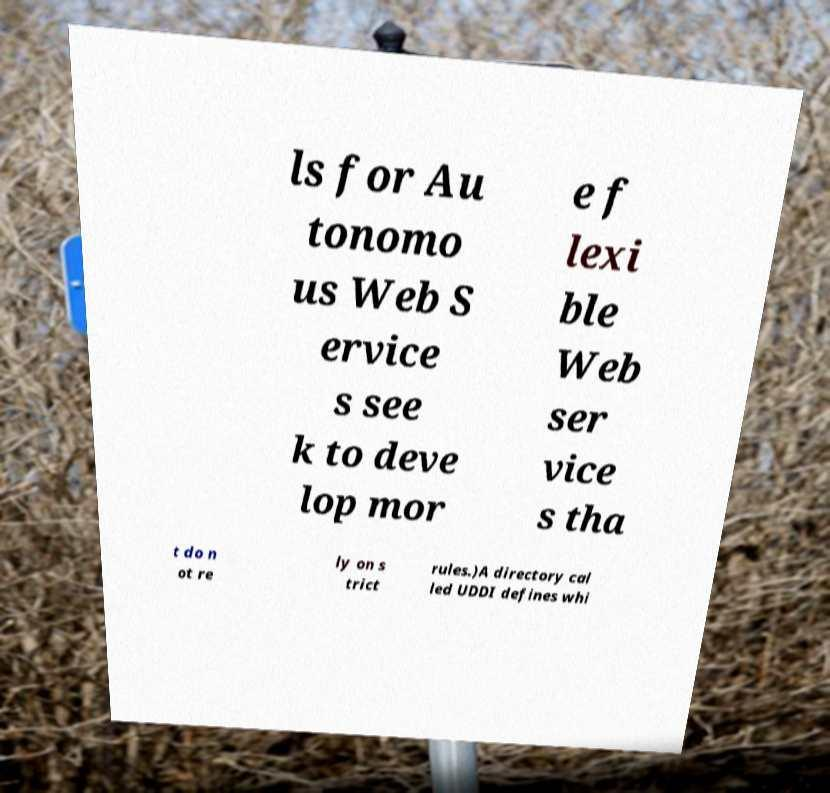Please read and relay the text visible in this image. What does it say? ls for Au tonomo us Web S ervice s see k to deve lop mor e f lexi ble Web ser vice s tha t do n ot re ly on s trict rules.)A directory cal led UDDI defines whi 